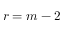<formula> <loc_0><loc_0><loc_500><loc_500>r = m - 2</formula> 